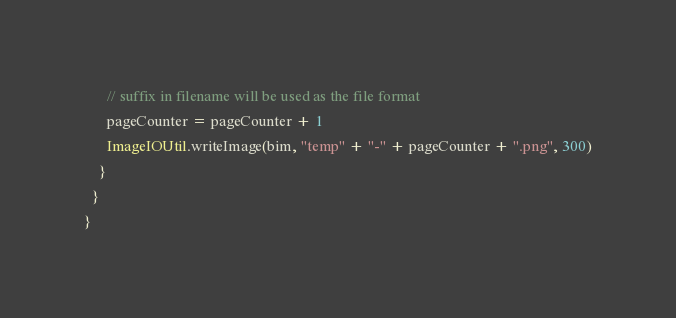Convert code to text. <code><loc_0><loc_0><loc_500><loc_500><_Scala_>      // suffix in filename will be used as the file format
      pageCounter = pageCounter + 1
      ImageIOUtil.writeImage(bim, "temp" + "-" + pageCounter + ".png", 300)
    }
  }
}</code> 